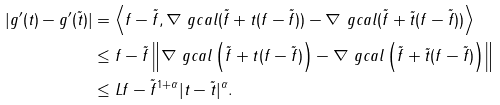<formula> <loc_0><loc_0><loc_500><loc_500>| g ^ { \prime } ( t ) - g ^ { \prime } ( \tilde { t } ) | & = \left \langle f - \tilde { f } , \nabla \ g c a l ( \tilde { f } + t ( f - \tilde { f } ) ) - \nabla \ g c a l ( \tilde { f } + \tilde { t } ( f - \tilde { f } ) ) \right \rangle \\ & \leq \| f - \tilde { f } \| \left \| \nabla \ g c a l \left ( \tilde { f } + t ( f - \tilde { f } ) \right ) - \nabla \ g c a l \left ( \tilde { f } + \tilde { t } ( f - \tilde { f } ) \right ) \right \| \\ & \leq L \| f - \tilde { f } \| ^ { 1 + \alpha } | t - \tilde { t } | ^ { \alpha } .</formula> 